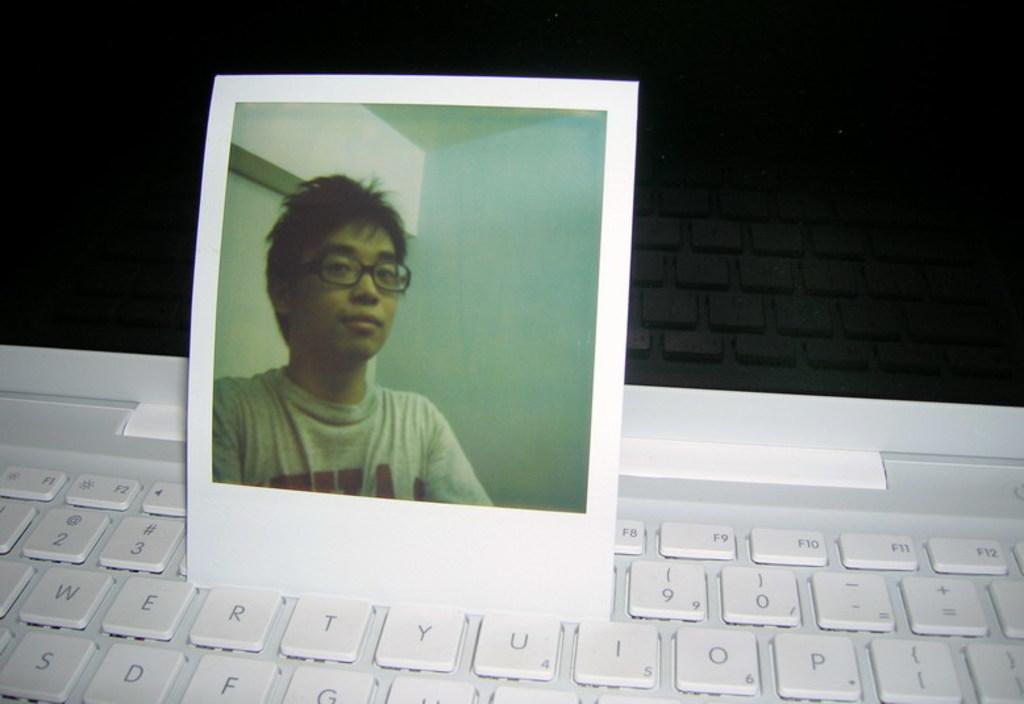How would you summarize this image in a sentence or two? In the image there is a photograph of a boy on a laptop. 